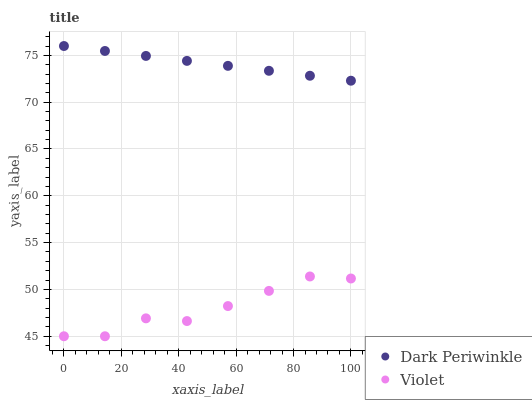Does Violet have the minimum area under the curve?
Answer yes or no. Yes. Does Dark Periwinkle have the maximum area under the curve?
Answer yes or no. Yes. Does Violet have the maximum area under the curve?
Answer yes or no. No. Is Dark Periwinkle the smoothest?
Answer yes or no. Yes. Is Violet the roughest?
Answer yes or no. Yes. Is Violet the smoothest?
Answer yes or no. No. Does Violet have the lowest value?
Answer yes or no. Yes. Does Dark Periwinkle have the highest value?
Answer yes or no. Yes. Does Violet have the highest value?
Answer yes or no. No. Is Violet less than Dark Periwinkle?
Answer yes or no. Yes. Is Dark Periwinkle greater than Violet?
Answer yes or no. Yes. Does Violet intersect Dark Periwinkle?
Answer yes or no. No. 